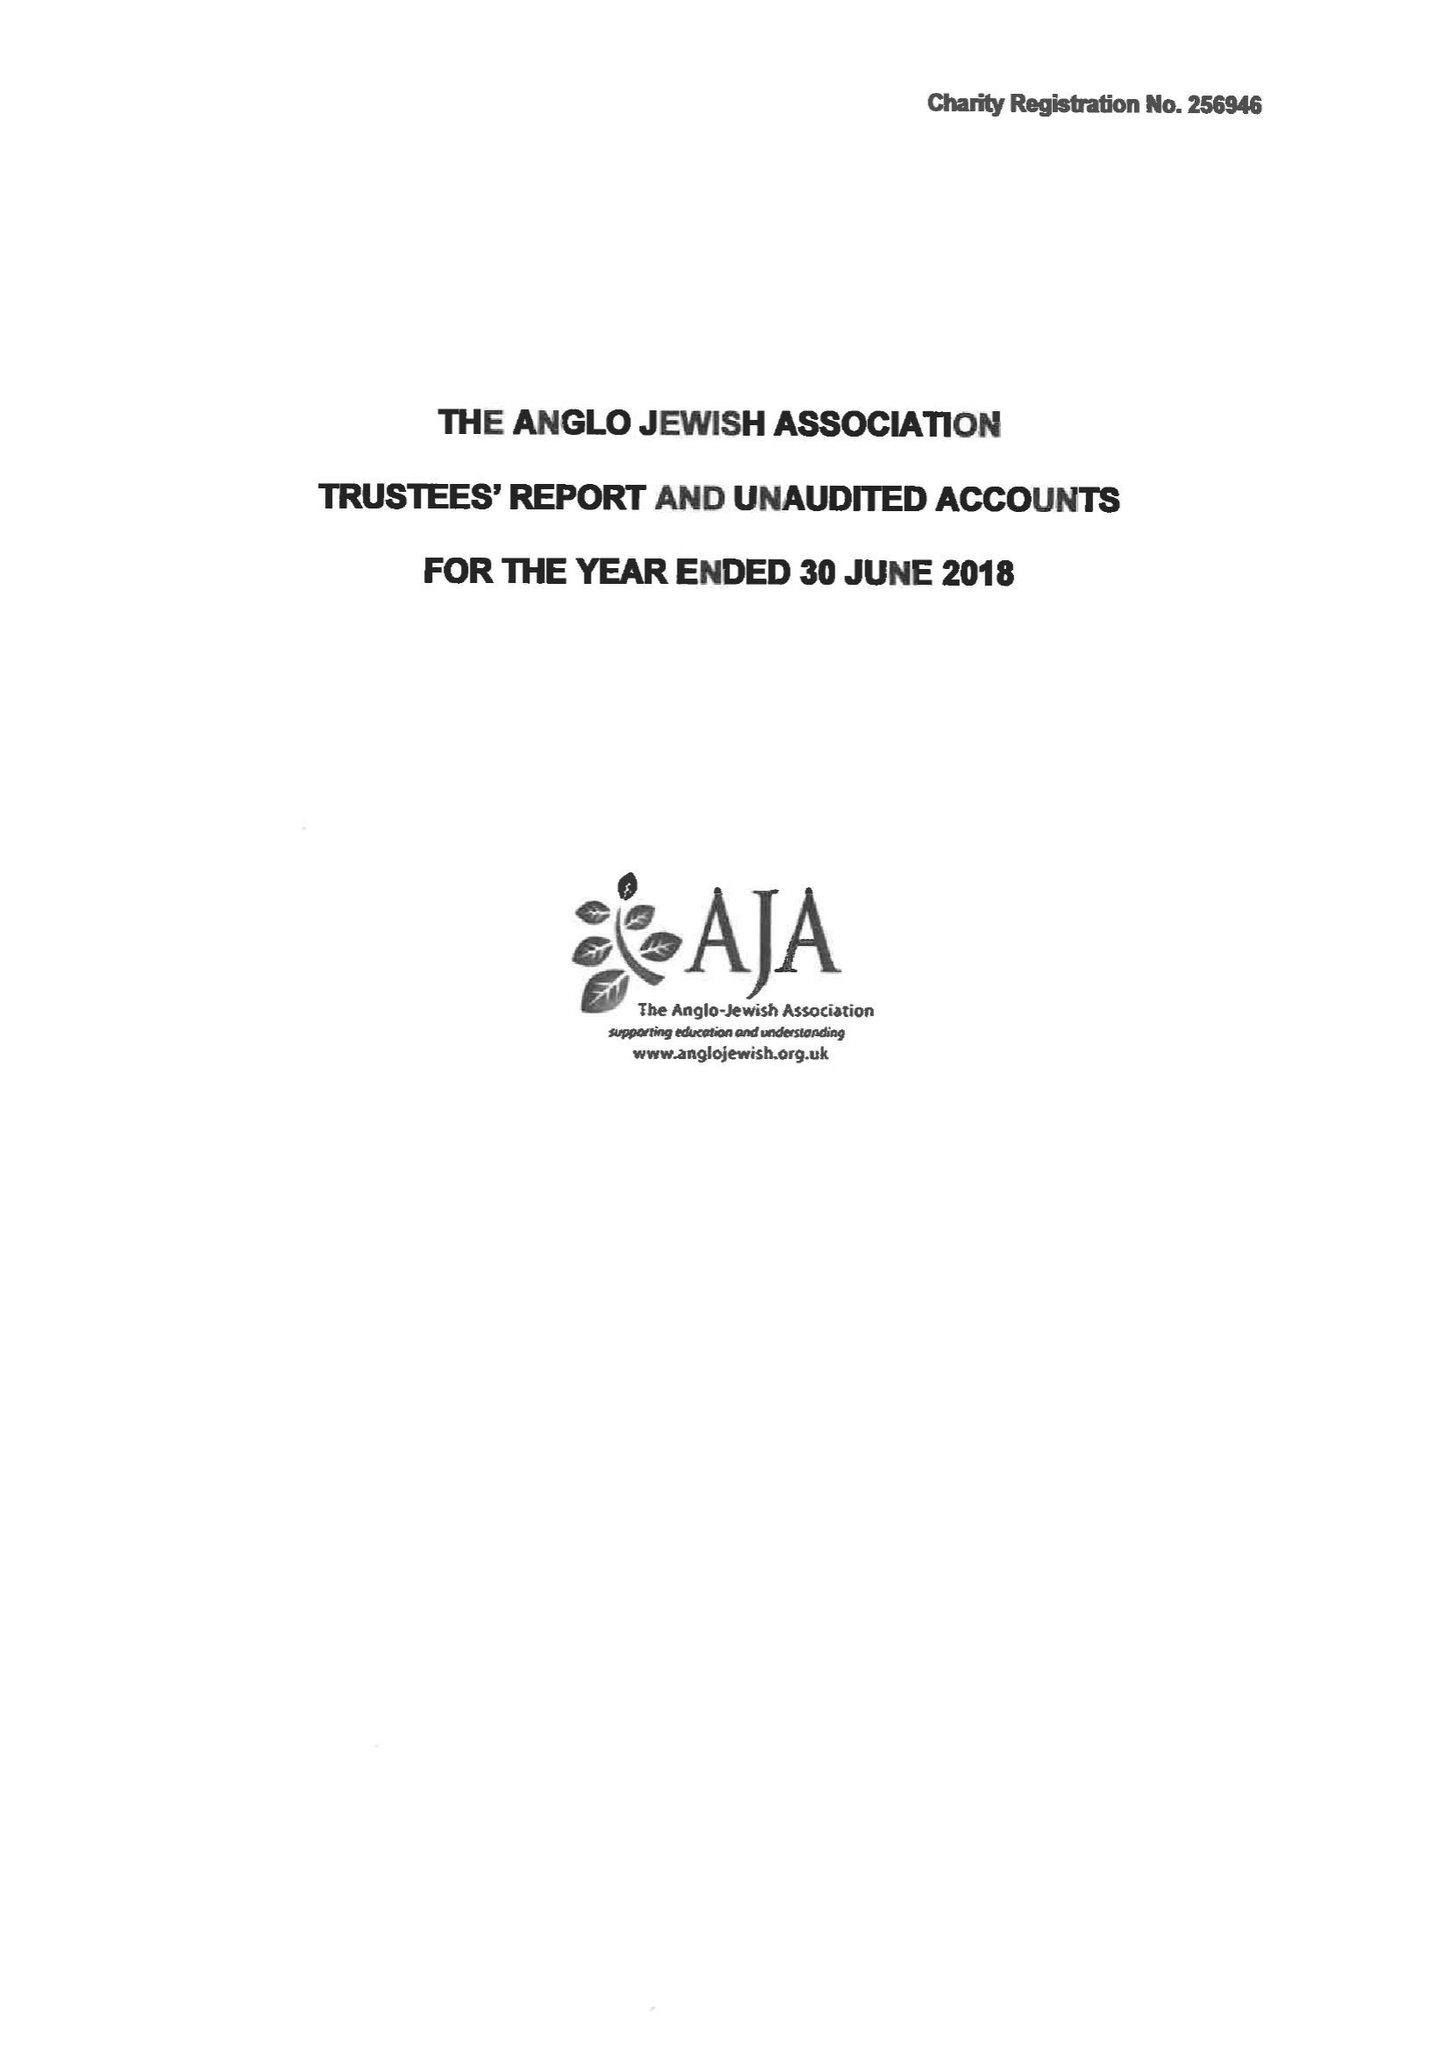What is the value for the income_annually_in_british_pounds?
Answer the question using a single word or phrase. 29515.00 